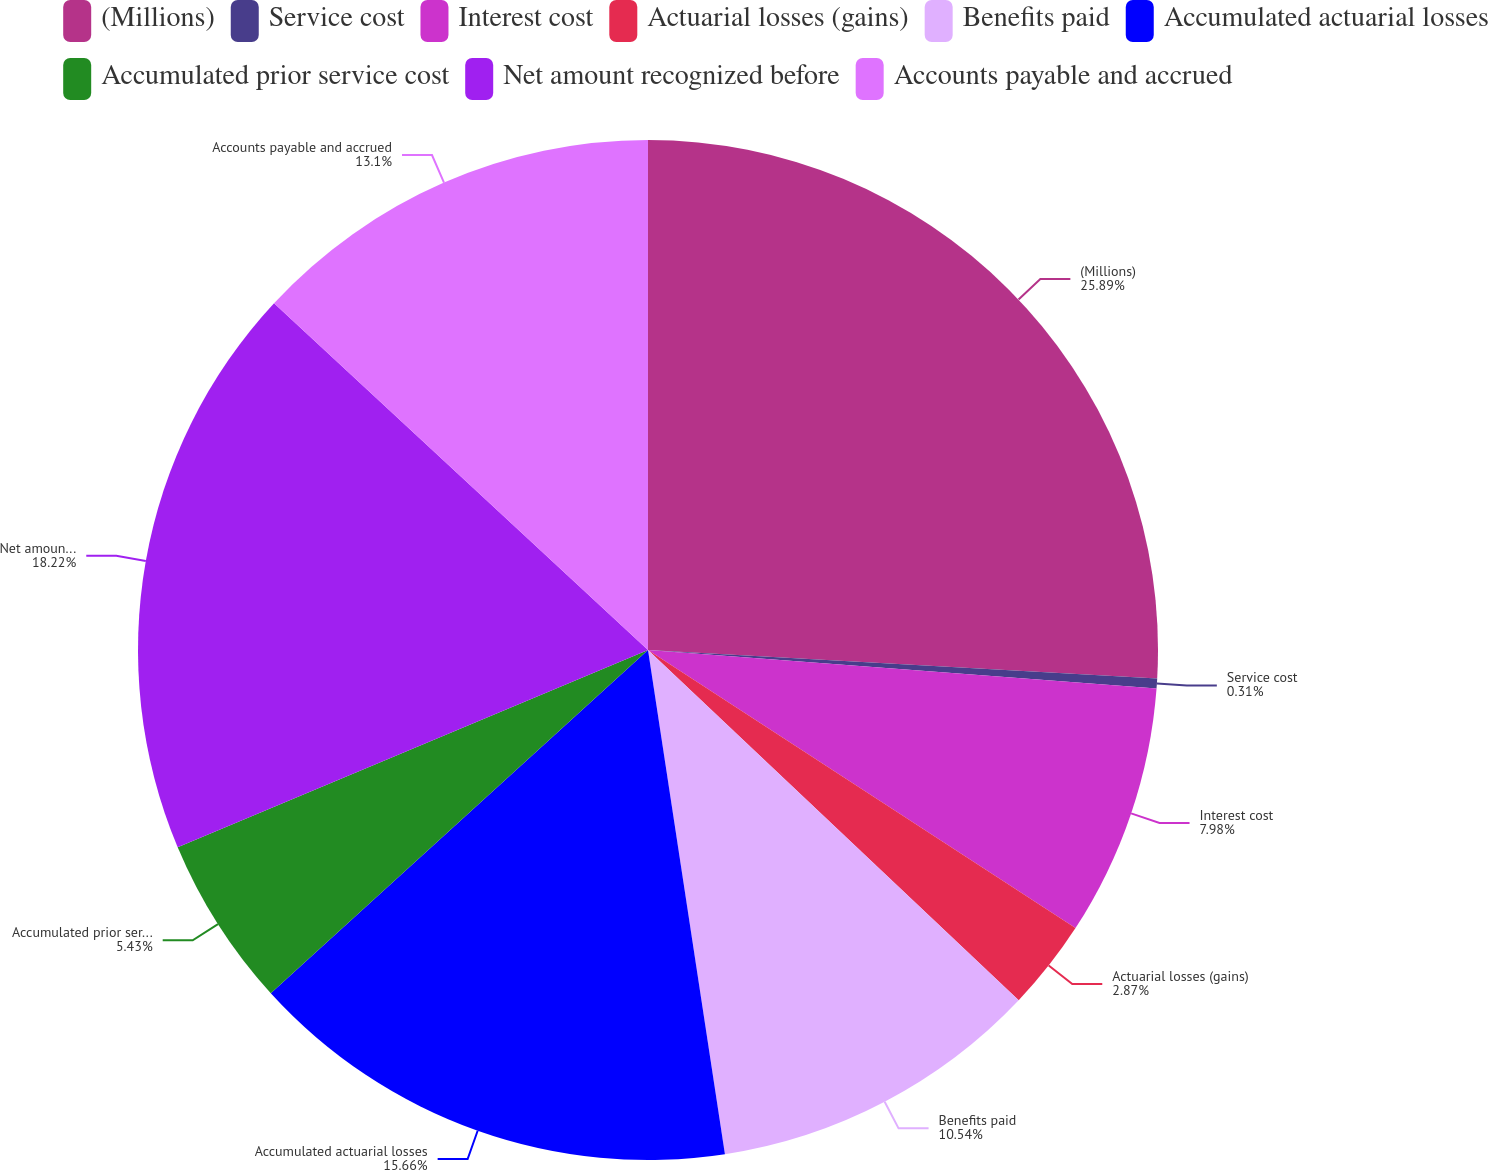<chart> <loc_0><loc_0><loc_500><loc_500><pie_chart><fcel>(Millions)<fcel>Service cost<fcel>Interest cost<fcel>Actuarial losses (gains)<fcel>Benefits paid<fcel>Accumulated actuarial losses<fcel>Accumulated prior service cost<fcel>Net amount recognized before<fcel>Accounts payable and accrued<nl><fcel>25.89%<fcel>0.31%<fcel>7.98%<fcel>2.87%<fcel>10.54%<fcel>15.66%<fcel>5.43%<fcel>18.22%<fcel>13.1%<nl></chart> 